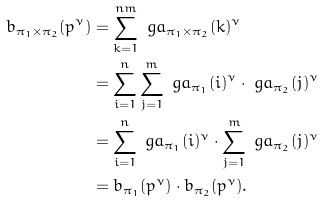<formula> <loc_0><loc_0><loc_500><loc_500>b _ { \pi _ { 1 } \times \pi _ { 2 } } ( p ^ { \nu } ) & = \sum _ { k = 1 } ^ { n m } \ g a _ { \pi _ { 1 } \times \pi _ { 2 } } ( k ) ^ { \nu } \\ & = \sum _ { i = 1 } ^ { n } \sum _ { j = 1 } ^ { m } \ g a _ { \pi _ { 1 } } ( i ) ^ { \nu } \cdot \ g a _ { \pi _ { 2 } } ( j ) ^ { \nu } \\ & = \sum _ { i = 1 } ^ { n } \ g a _ { \pi _ { 1 } } ( i ) ^ { \nu } \cdot \sum _ { j = 1 } ^ { m } \ g a _ { \pi _ { 2 } } ( j ) ^ { \nu } \\ & = b _ { \pi _ { 1 } } ( p ^ { \nu } ) \cdot b _ { \pi _ { 2 } } ( p ^ { \nu } ) .</formula> 